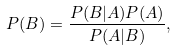<formula> <loc_0><loc_0><loc_500><loc_500>P ( B ) = \frac { P ( B | A ) P ( A ) } { P ( A | B ) } ,</formula> 